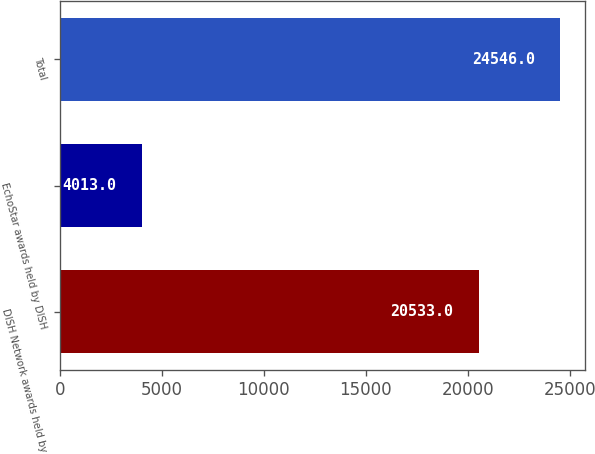<chart> <loc_0><loc_0><loc_500><loc_500><bar_chart><fcel>DISH Network awards held by<fcel>EchoStar awards held by DISH<fcel>Total<nl><fcel>20533<fcel>4013<fcel>24546<nl></chart> 